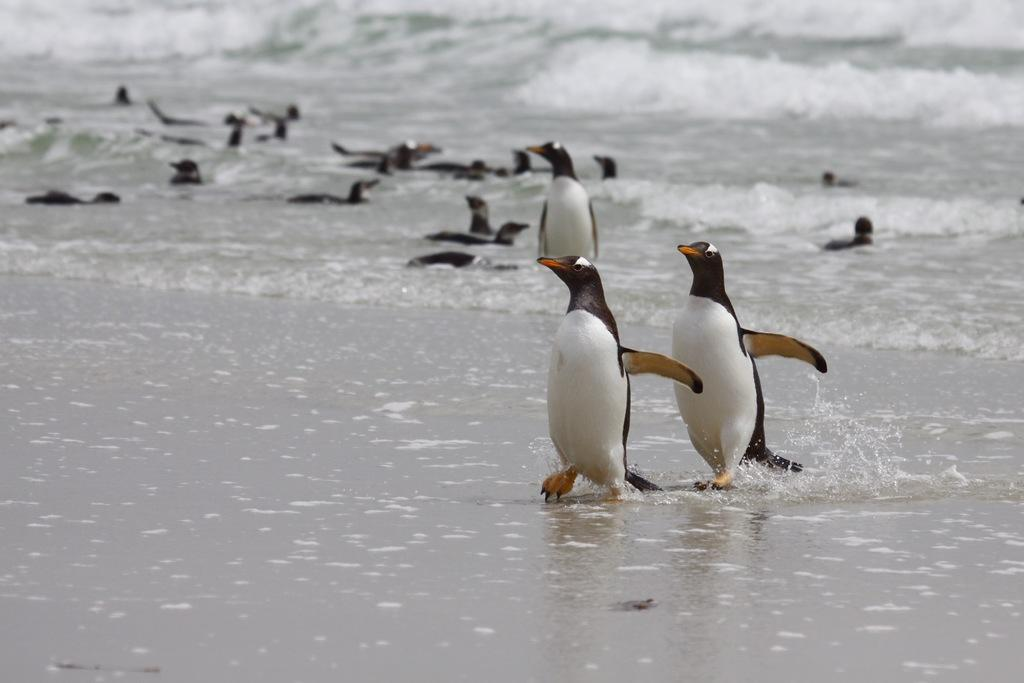What type of animals are in the image? There are penguins in the image. Where are the penguins located? The penguins are in the water. What type of water can be seen in the image? There is water visible in the image, which appears to be part of an ocean. What type of trick can be seen being performed by the penguins in the image? There is no trick being performed by the penguins in the image; they are simply swimming in the water. 